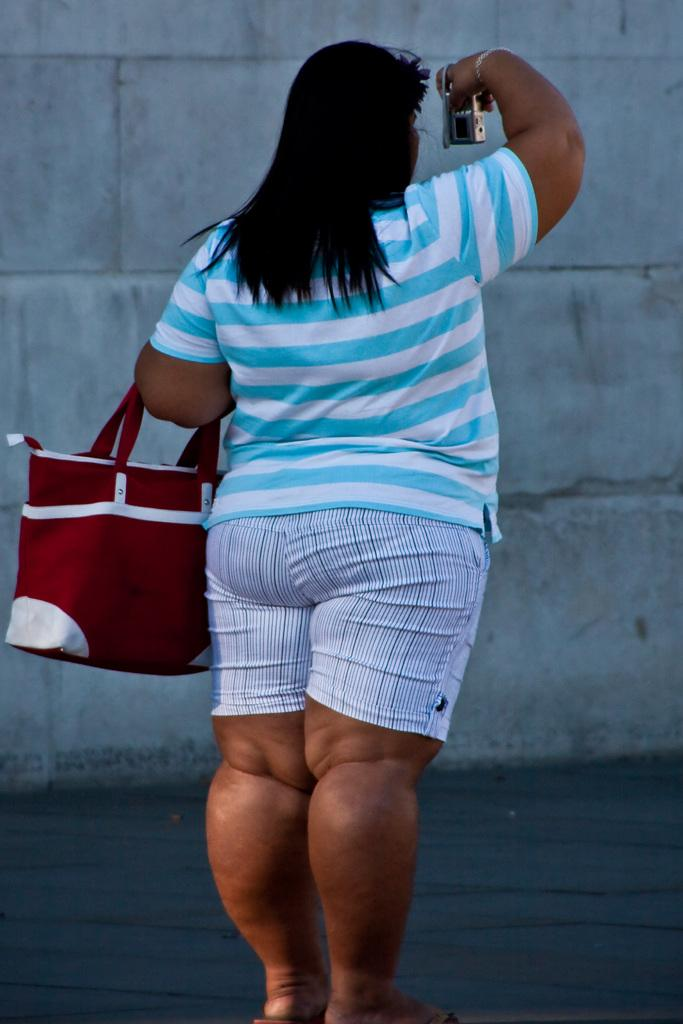What is the main subject of the picture? The main subject of the picture is a woman. What type of clothing is the woman wearing? The woman is wearing a t-shirt and shorts. What type of footwear is the woman wearing? The woman is wearing sleeper shoes. What is the woman holding in the picture? The woman is holding a camera and a red purse. What can be seen in the background of the picture? There is a wall in the background of the picture. What direction is the gate facing in the image? There is no gate present in the image. How quiet is the environment in the image? The provided facts do not give any information about the noise level or environment's quietness. 